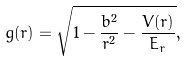<formula> <loc_0><loc_0><loc_500><loc_500>g ( r ) = \sqrt { 1 - \frac { b ^ { 2 } } { r ^ { 2 } } - \frac { V ( r ) } { E _ { r } } } ,</formula> 